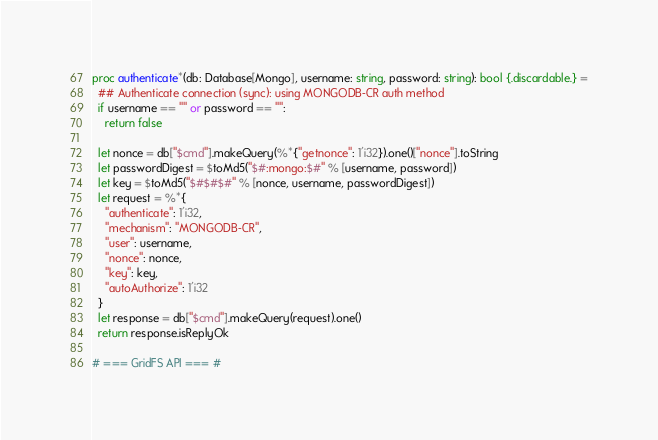Convert code to text. <code><loc_0><loc_0><loc_500><loc_500><_Nim_>
proc authenticate*(db: Database[Mongo], username: string, password: string): bool {.discardable.} =
  ## Authenticate connection (sync): using MONGODB-CR auth method
  if username == "" or password == "":
    return false

  let nonce = db["$cmd"].makeQuery(%*{"getnonce": 1'i32}).one()["nonce"].toString
  let passwordDigest = $toMd5("$#:mongo:$#" % [username, password])
  let key = $toMd5("$#$#$#" % [nonce, username, passwordDigest])
  let request = %*{
    "authenticate": 1'i32,
    "mechanism": "MONGODB-CR",
    "user": username,
    "nonce": nonce,
    "key": key,
    "autoAuthorize": 1'i32
  }
  let response = db["$cmd"].makeQuery(request).one()
  return response.isReplyOk

# === GridFS API === #
</code> 